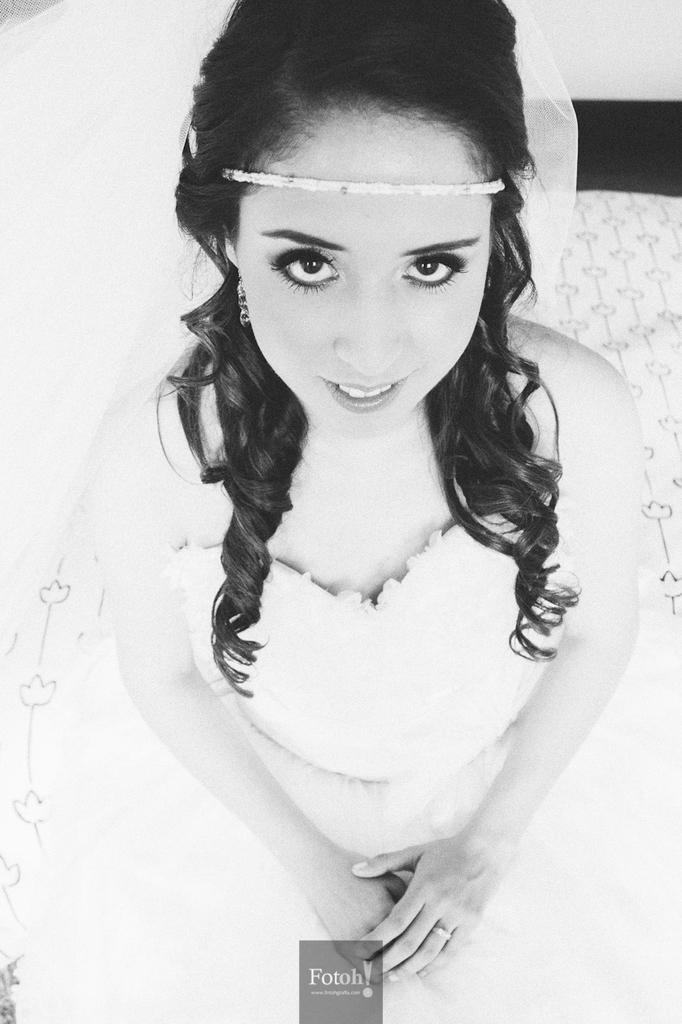What is the person in the image wearing? The person in the image is wearing a white dress. Can you describe any additional accessories the person is wearing? The person has a veil on her head. Is there any other detail about the image that stands out? Yes, there is a watermark in the image. What type of cow can be seen in the image? There is no cow present in the image. How many goats are visible in the image? There are no goats present in the image. 